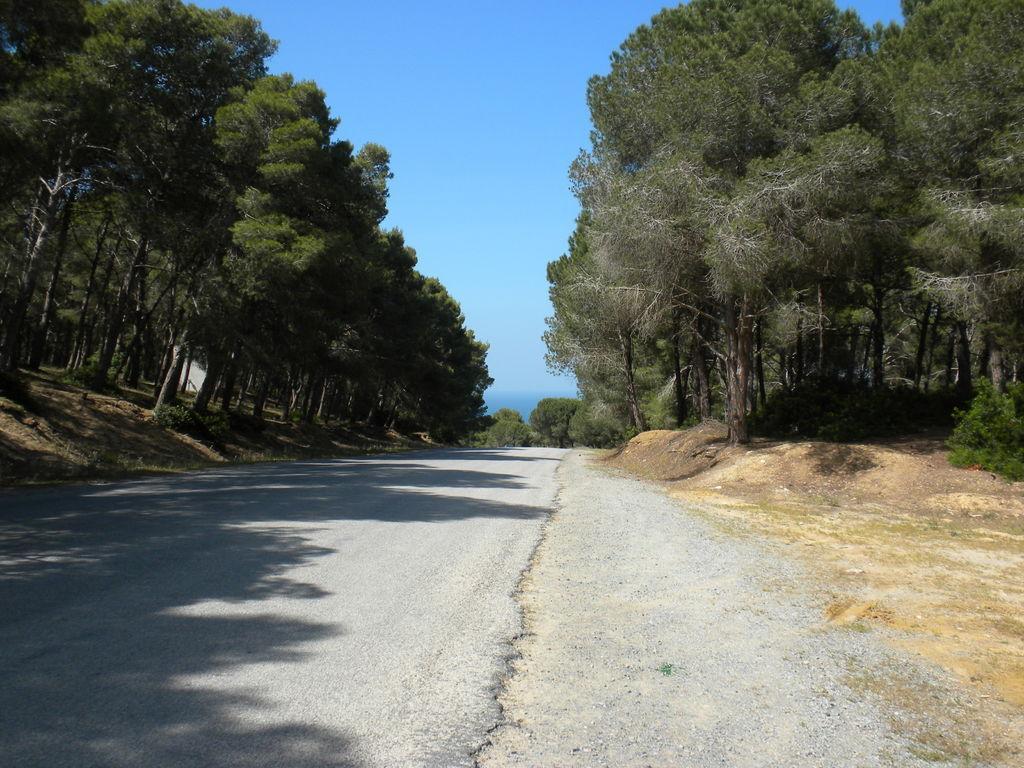How would you summarize this image in a sentence or two? In this image we can see the road. Here we can see the trees on both sides of the road. This is a sky with clouds. 